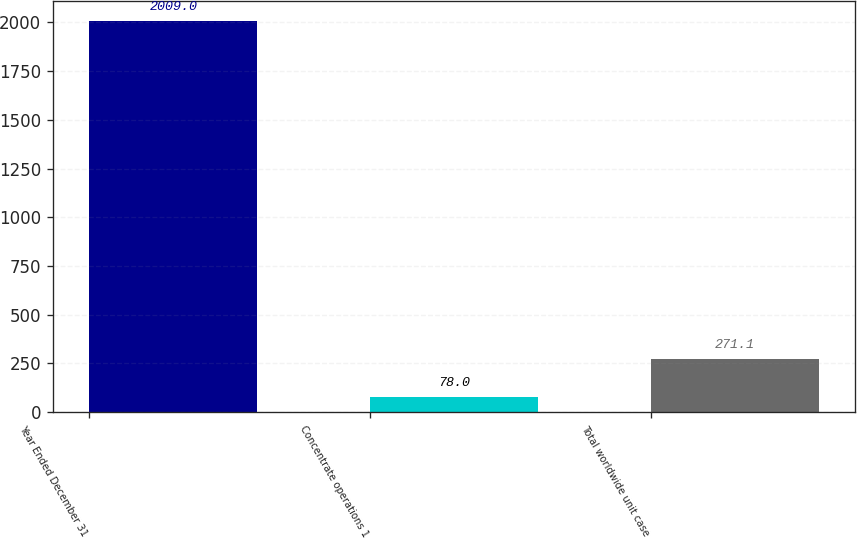Convert chart to OTSL. <chart><loc_0><loc_0><loc_500><loc_500><bar_chart><fcel>Year Ended December 31<fcel>Concentrate operations 1<fcel>Total worldwide unit case<nl><fcel>2009<fcel>78<fcel>271.1<nl></chart> 